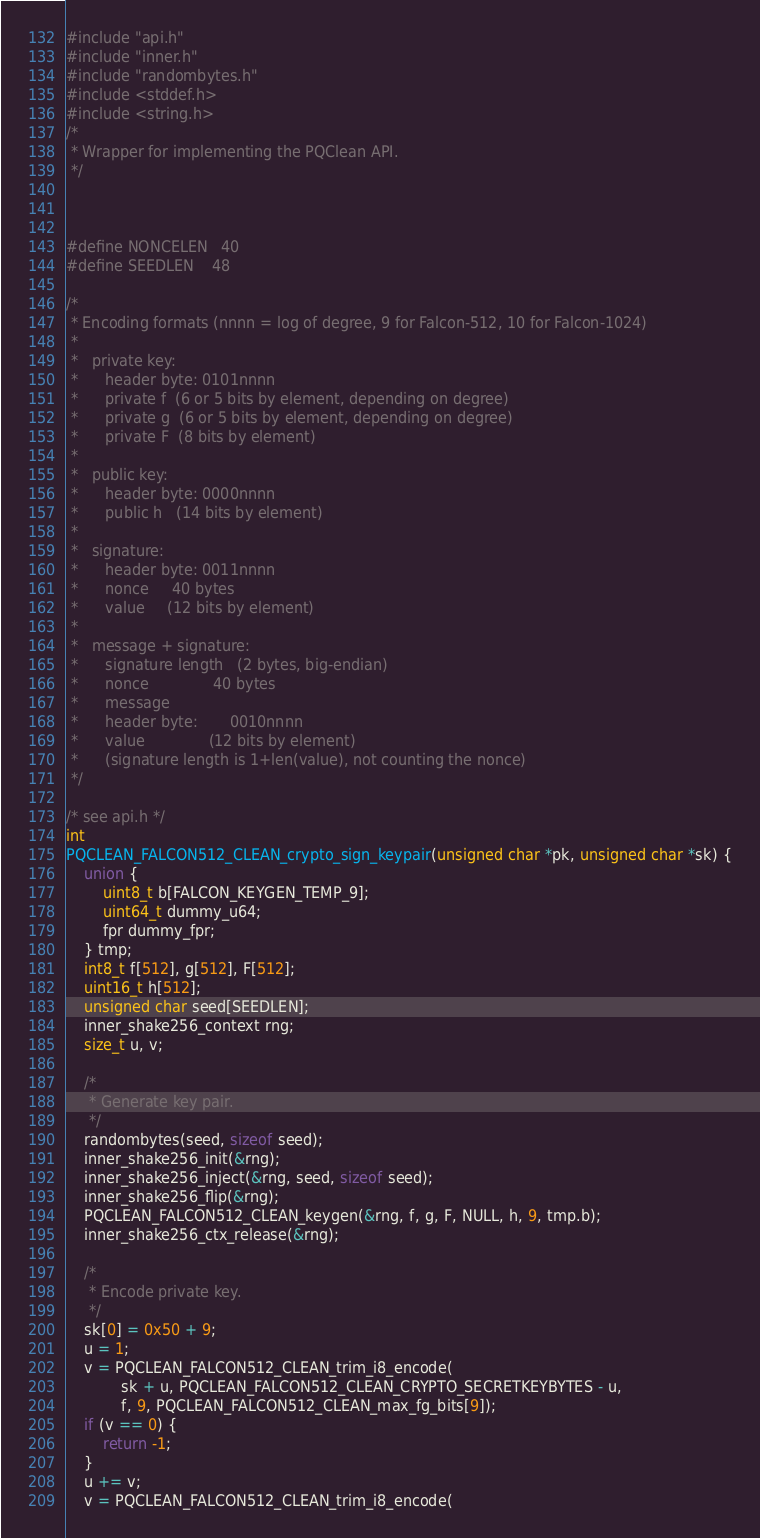<code> <loc_0><loc_0><loc_500><loc_500><_C++_>#include "api.h"
#include "inner.h"
#include "randombytes.h"
#include <stddef.h>
#include <string.h>
/*
 * Wrapper for implementing the PQClean API.
 */



#define NONCELEN   40
#define SEEDLEN    48

/*
 * Encoding formats (nnnn = log of degree, 9 for Falcon-512, 10 for Falcon-1024)
 *
 *   private key:
 *      header byte: 0101nnnn
 *      private f  (6 or 5 bits by element, depending on degree)
 *      private g  (6 or 5 bits by element, depending on degree)
 *      private F  (8 bits by element)
 *
 *   public key:
 *      header byte: 0000nnnn
 *      public h   (14 bits by element)
 *
 *   signature:
 *      header byte: 0011nnnn
 *      nonce     40 bytes
 *      value     (12 bits by element)
 *
 *   message + signature:
 *      signature length   (2 bytes, big-endian)
 *      nonce              40 bytes
 *      message
 *      header byte:       0010nnnn
 *      value              (12 bits by element)
 *      (signature length is 1+len(value), not counting the nonce)
 */

/* see api.h */
int
PQCLEAN_FALCON512_CLEAN_crypto_sign_keypair(unsigned char *pk, unsigned char *sk) {
    union {
        uint8_t b[FALCON_KEYGEN_TEMP_9];
        uint64_t dummy_u64;
        fpr dummy_fpr;
    } tmp;
    int8_t f[512], g[512], F[512];
    uint16_t h[512];
    unsigned char seed[SEEDLEN];
    inner_shake256_context rng;
    size_t u, v;

    /*
     * Generate key pair.
     */
    randombytes(seed, sizeof seed);
    inner_shake256_init(&rng);
    inner_shake256_inject(&rng, seed, sizeof seed);
    inner_shake256_flip(&rng);
    PQCLEAN_FALCON512_CLEAN_keygen(&rng, f, g, F, NULL, h, 9, tmp.b);
    inner_shake256_ctx_release(&rng);

    /*
     * Encode private key.
     */
    sk[0] = 0x50 + 9;
    u = 1;
    v = PQCLEAN_FALCON512_CLEAN_trim_i8_encode(
            sk + u, PQCLEAN_FALCON512_CLEAN_CRYPTO_SECRETKEYBYTES - u,
            f, 9, PQCLEAN_FALCON512_CLEAN_max_fg_bits[9]);
    if (v == 0) {
        return -1;
    }
    u += v;
    v = PQCLEAN_FALCON512_CLEAN_trim_i8_encode(</code> 